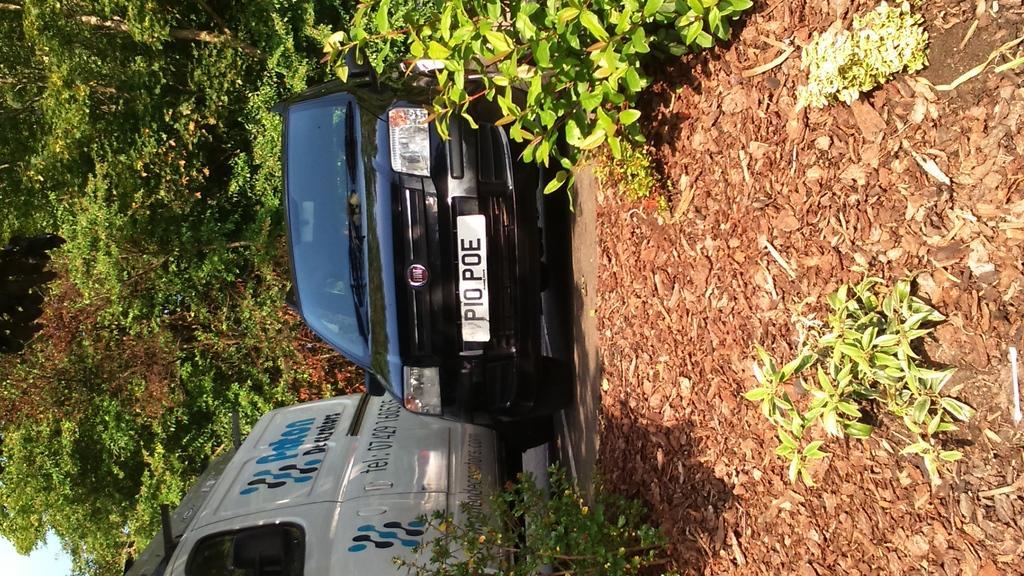Describe this image in one or two sentences. In the image there are two vehicles parked beside a land that is filled with dry leaves and behind the vehicles there are a lot of trees. 